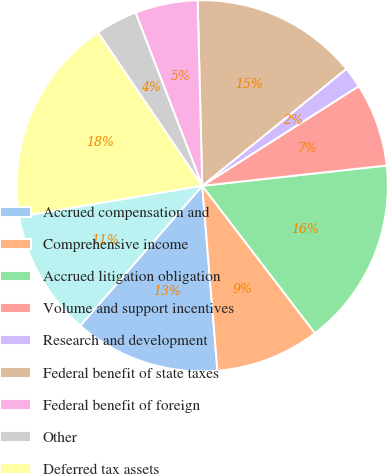Convert chart. <chart><loc_0><loc_0><loc_500><loc_500><pie_chart><fcel>Accrued compensation and<fcel>Comprehensive income<fcel>Accrued litigation obligation<fcel>Volume and support incentives<fcel>Research and development<fcel>Federal benefit of state taxes<fcel>Federal benefit of foreign<fcel>Other<fcel>Deferred tax assets<fcel>Property equipment and<nl><fcel>12.72%<fcel>9.09%<fcel>16.35%<fcel>7.28%<fcel>1.83%<fcel>14.54%<fcel>5.46%<fcel>3.65%<fcel>18.17%<fcel>10.91%<nl></chart> 